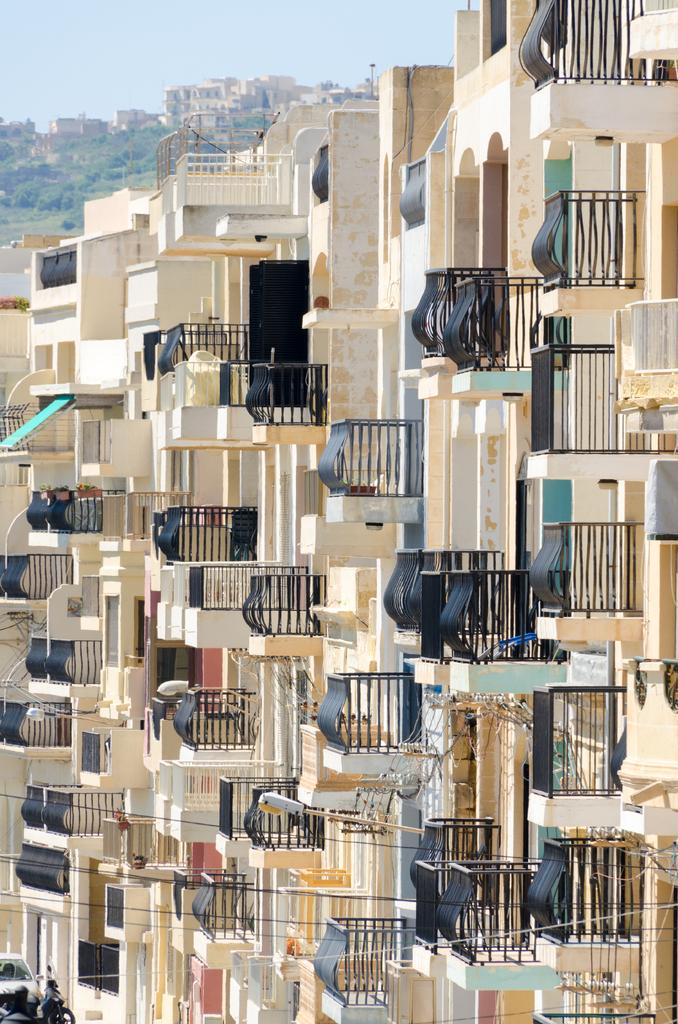What structures are located in the middle of the image? There are buildings in the middle of the image. What type of vegetation can be seen in the background of the image? There are trees in the background of the image. What is visible at the top of the image? The sky is visible at the top of the image. What does your dad hate about the image? There is no reference to a dad or any emotions in the image, so it's not possible to determine what your dad might hate about the image. 